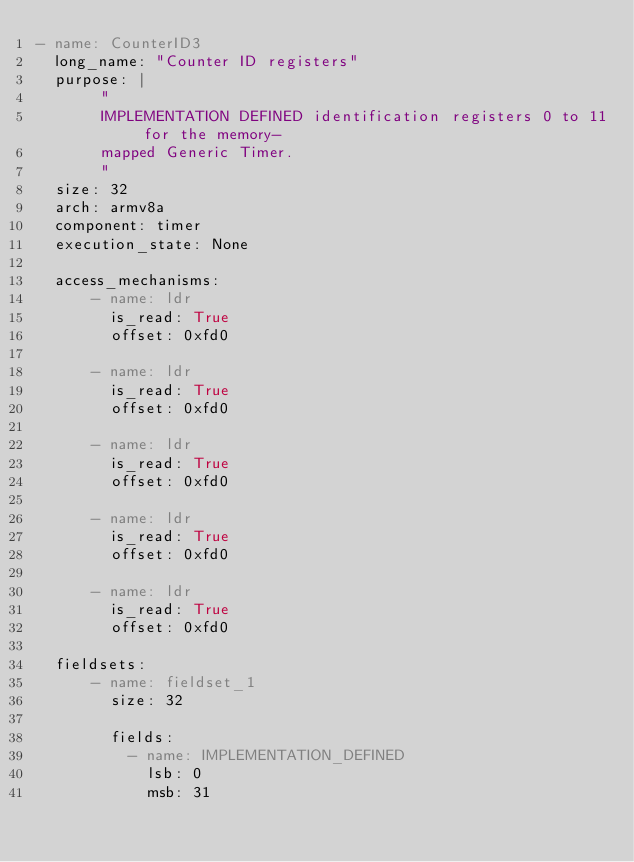<code> <loc_0><loc_0><loc_500><loc_500><_YAML_>- name: CounterID3
  long_name: "Counter ID registers"
  purpose: |
       "
       IMPLEMENTATION DEFINED identification registers 0 to 11 for the memory-
       mapped Generic Timer.
       "
  size: 32
  arch: armv8a
  component: timer
  execution_state: None

  access_mechanisms:
      - name: ldr
        is_read: True
        offset: 0xfd0

      - name: ldr
        is_read: True
        offset: 0xfd0

      - name: ldr
        is_read: True
        offset: 0xfd0

      - name: ldr
        is_read: True
        offset: 0xfd0

      - name: ldr
        is_read: True
        offset: 0xfd0

  fieldsets:
      - name: fieldset_1
        size: 32

        fields:
          - name: IMPLEMENTATION_DEFINED
            lsb: 0
            msb: 31
</code> 